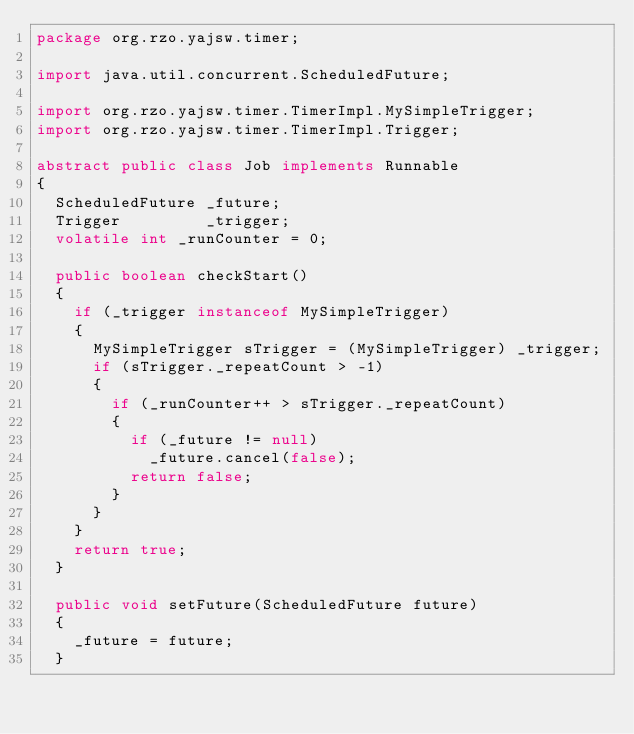Convert code to text. <code><loc_0><loc_0><loc_500><loc_500><_Java_>package org.rzo.yajsw.timer;

import java.util.concurrent.ScheduledFuture;

import org.rzo.yajsw.timer.TimerImpl.MySimpleTrigger;
import org.rzo.yajsw.timer.TimerImpl.Trigger;

abstract public class Job implements Runnable
{
	ScheduledFuture _future;
	Trigger         _trigger;
	volatile int _runCounter = 0;
	
	public boolean checkStart()
	{
		if (_trigger instanceof MySimpleTrigger)
		{
			MySimpleTrigger sTrigger = (MySimpleTrigger) _trigger;
			if (sTrigger._repeatCount > -1)
			{
				if (_runCounter++ > sTrigger._repeatCount)
				{
					if (_future != null)
						_future.cancel(false);
					return false;
				}
			}
		}
		return true;
	}

	public void setFuture(ScheduledFuture future)
	{
		_future = future;
	}
</code> 